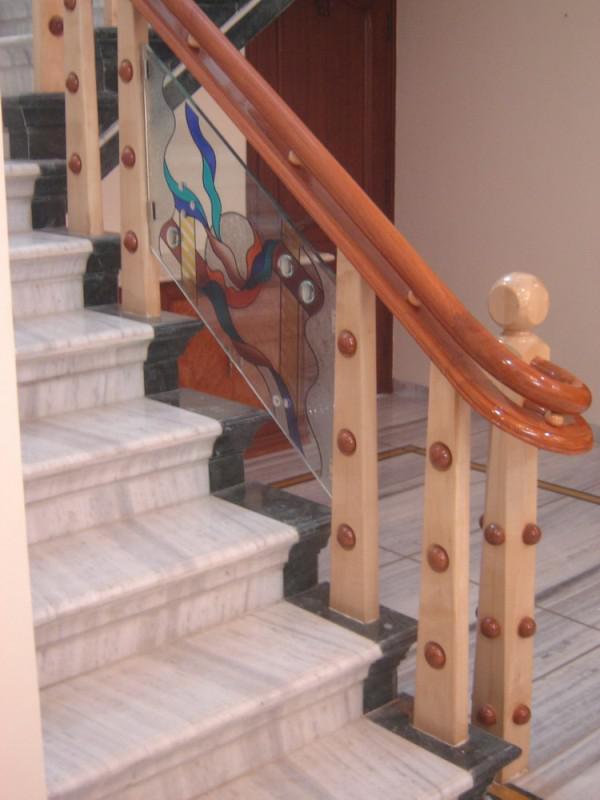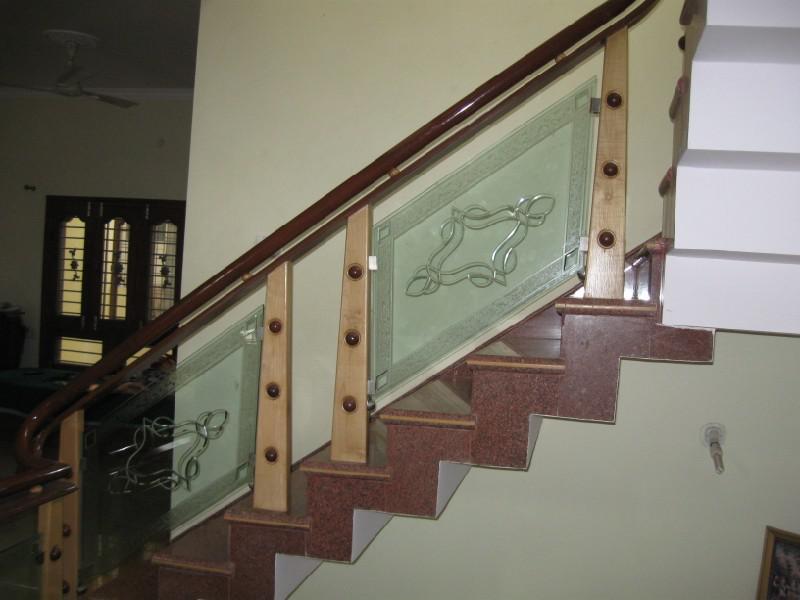The first image is the image on the left, the second image is the image on the right. Examine the images to the left and right. Is the description "The vertical posts on the stairway are all wood." accurate? Answer yes or no. Yes. 